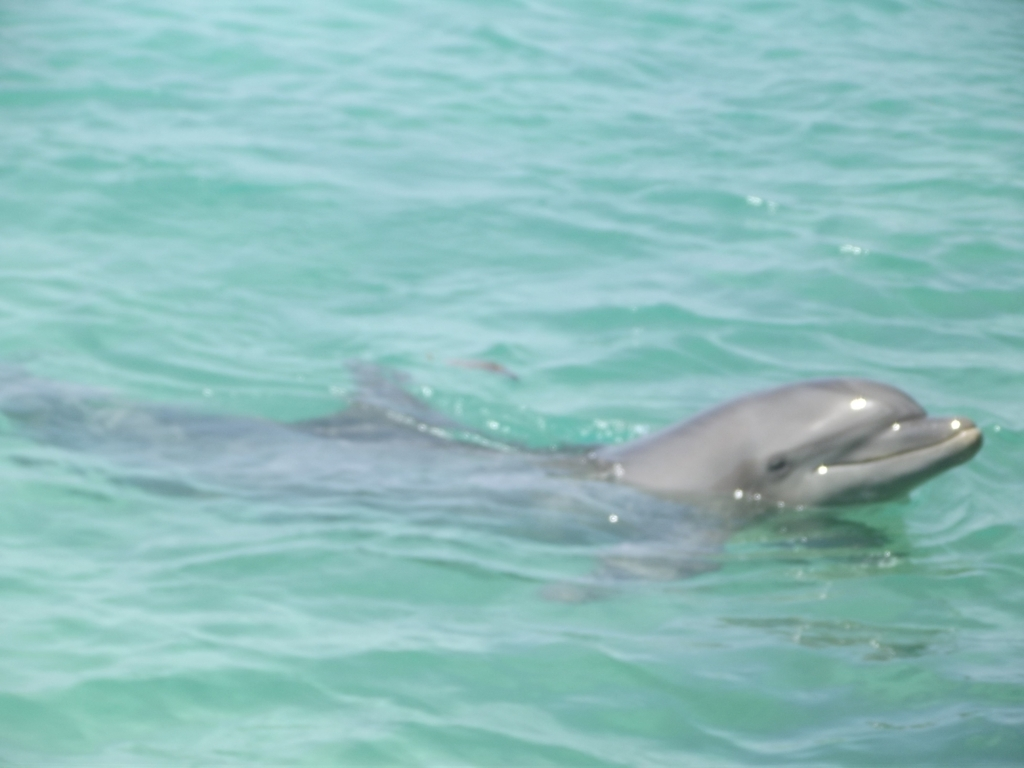Is this species of dolphin common, and what are its characteristics? The dolphin in the image resembles a bottlenose dolphin, which is one of the most well-known and common species. They are characterized by a robust body, a large dorsal fin, and a long, curved mouth that gives the appearance of a friendly 'smile.' 